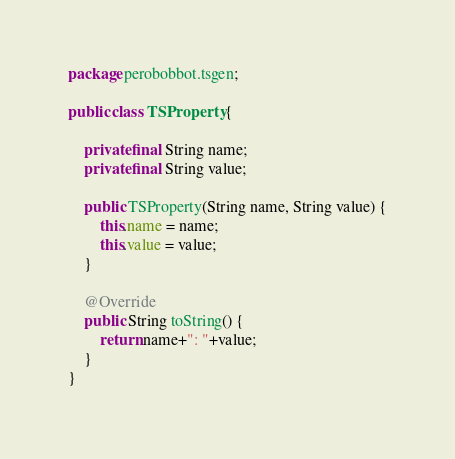<code> <loc_0><loc_0><loc_500><loc_500><_Java_>package perobobbot.tsgen;

public class TSProperty {

    private final String name;
    private final String value;

    public TSProperty(String name, String value) {
        this.name = name;
        this.value = value;
    }

    @Override
    public String toString() {
        return name+": "+value;
    }
}
</code> 